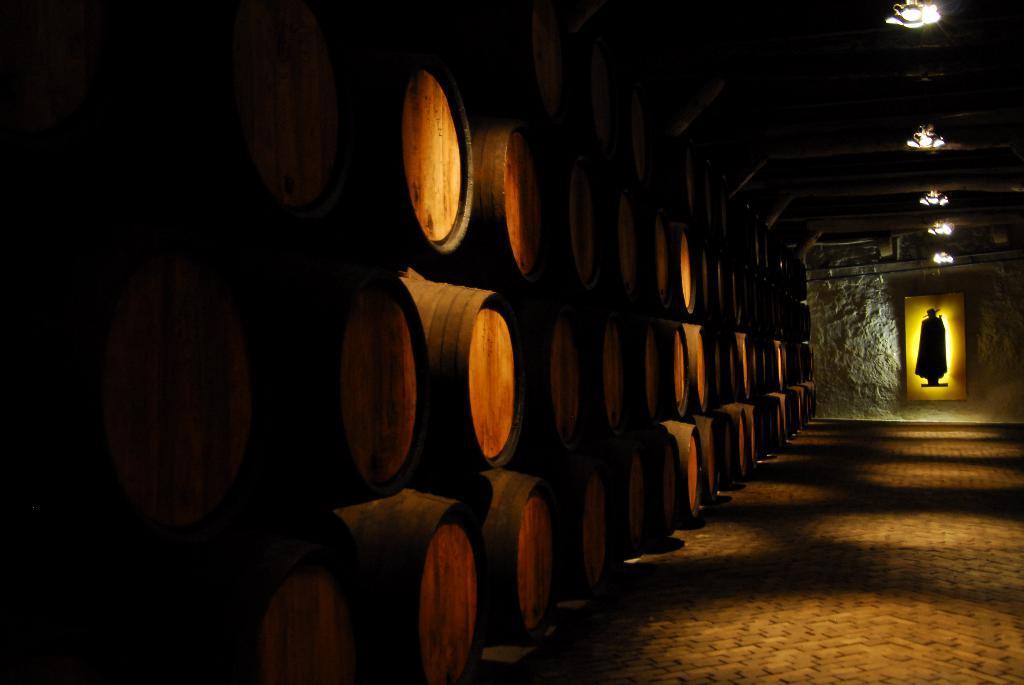Can you describe this image briefly? In this image I can observe barrels. At the top there are lights to the ceiling. 